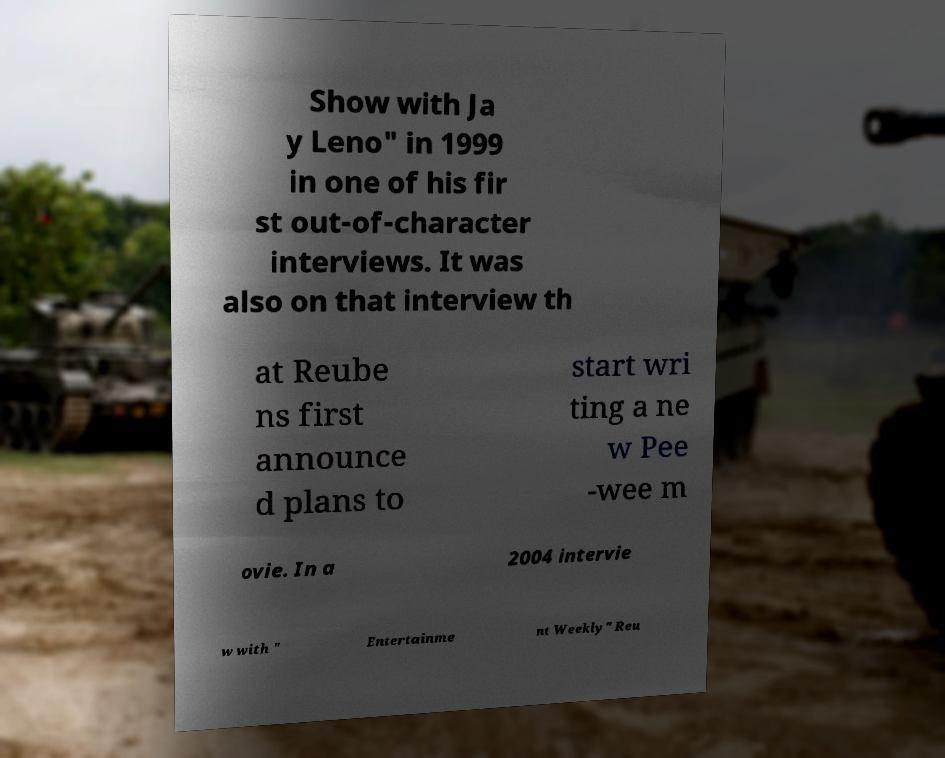For documentation purposes, I need the text within this image transcribed. Could you provide that? Show with Ja y Leno" in 1999 in one of his fir st out-of-character interviews. It was also on that interview th at Reube ns first announce d plans to start wri ting a ne w Pee -wee m ovie. In a 2004 intervie w with " Entertainme nt Weekly" Reu 